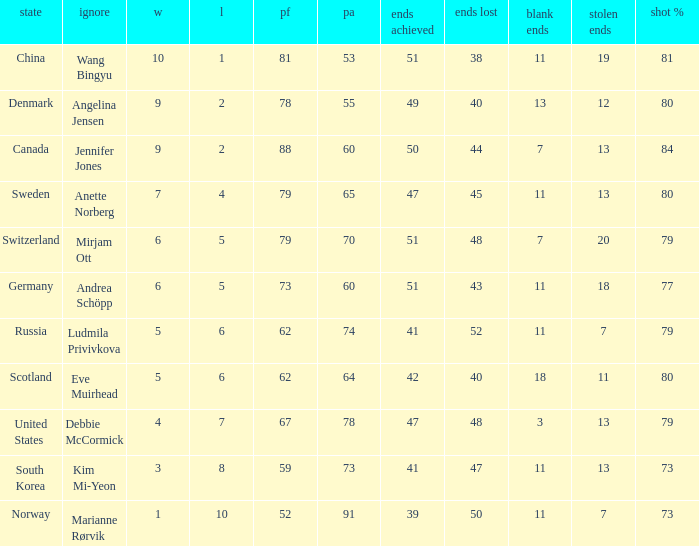What is Norway's least ends lost? 50.0. 